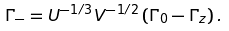Convert formula to latex. <formula><loc_0><loc_0><loc_500><loc_500>\Gamma _ { - } = U ^ { - 1 / 3 } V ^ { - 1 / 2 } \left ( \Gamma _ { 0 } - \Gamma _ { z } \right ) .</formula> 